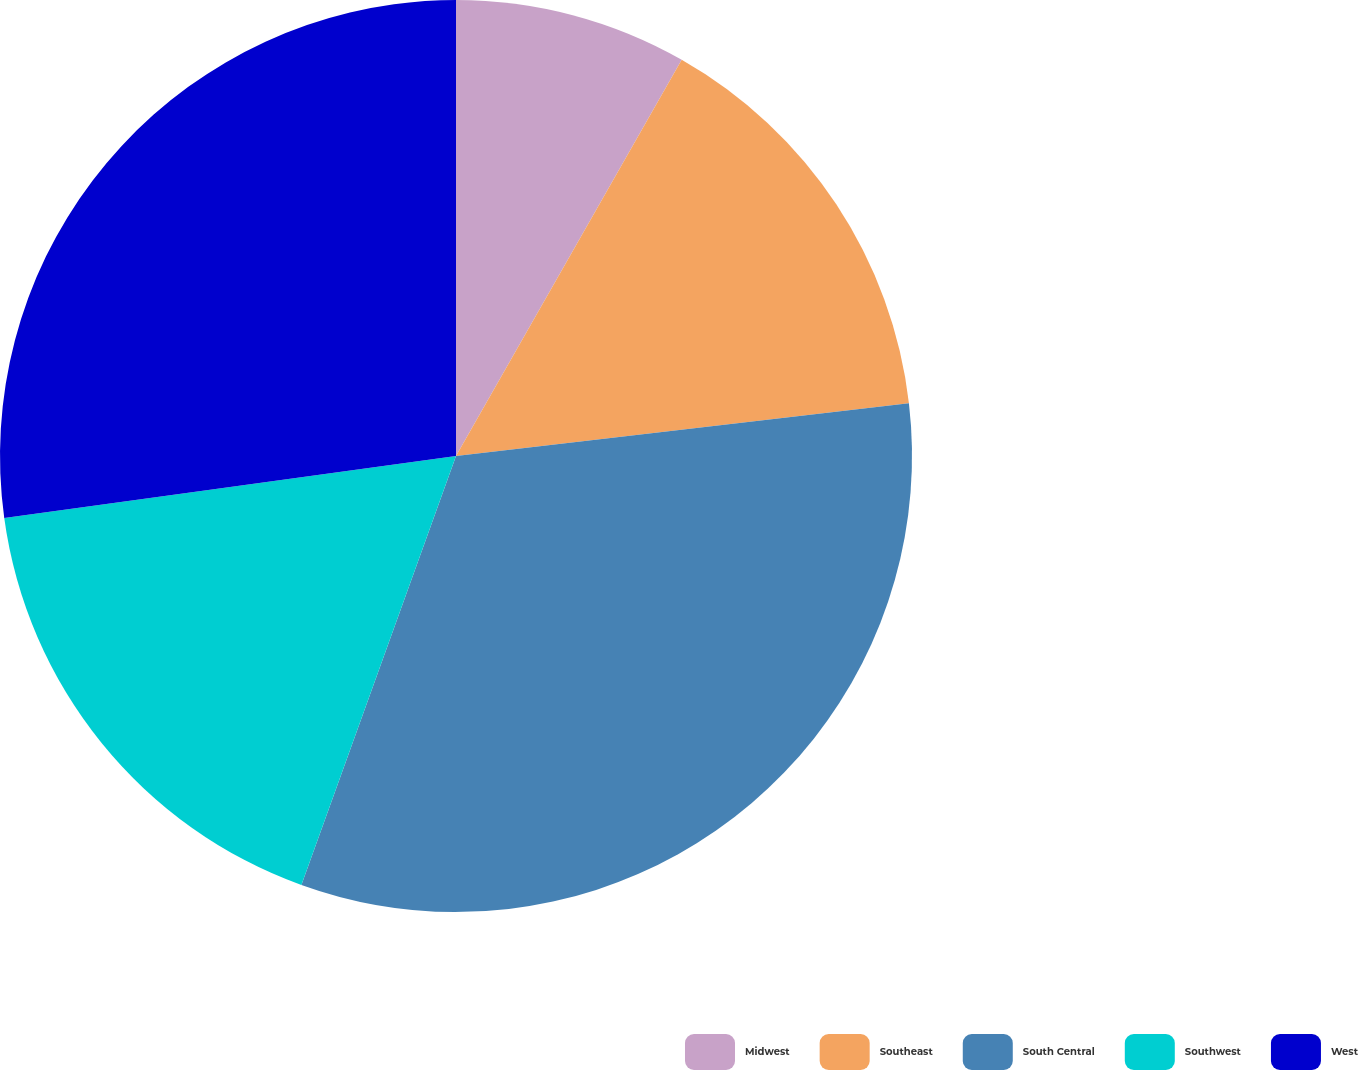Convert chart. <chart><loc_0><loc_0><loc_500><loc_500><pie_chart><fcel>Midwest<fcel>Southeast<fcel>South Central<fcel>Southwest<fcel>West<nl><fcel>8.24%<fcel>14.91%<fcel>32.35%<fcel>17.32%<fcel>27.17%<nl></chart> 